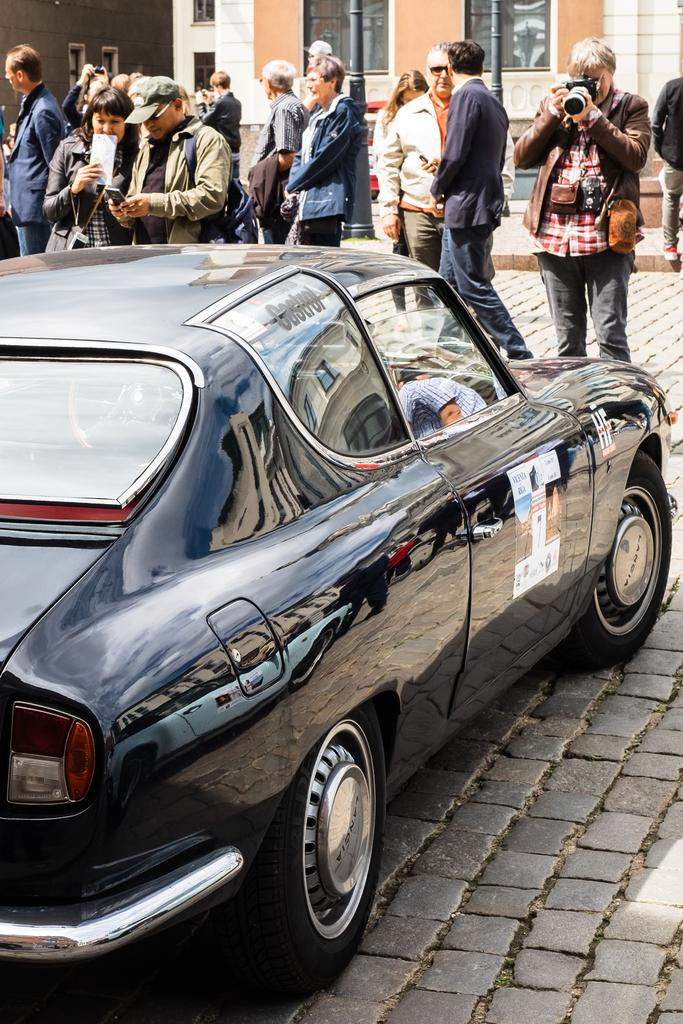What is the main subject of the image? There is a vehicle in the image. What are the people on the ground doing? One person is holding a camera, while others are likely observing or interacting with the vehicle. What can be seen in the background of the image? There is a building and other objects visible in the background of the image. What type of frame is being used by the person on stage in the image? There is no stage or person using a frame present in the image. What kind of apparatus is being used by the people in the image? The only specific object mentioned in the image is a camera, which is not an apparatus. The other objects in the background are not described in enough detail to determine if they are apparatuses. 